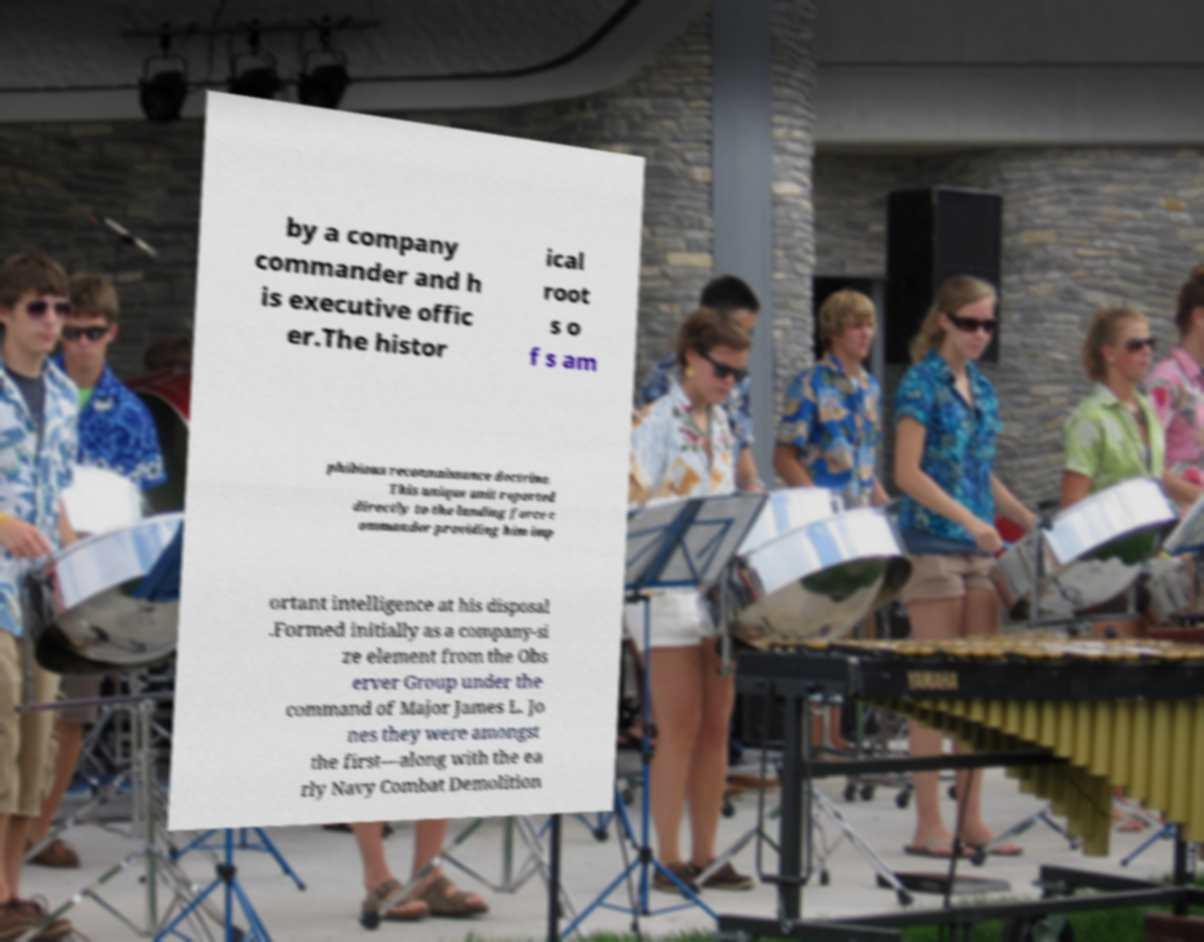Could you extract and type out the text from this image? by a company commander and h is executive offic er.The histor ical root s o f s am phibious reconnaissance doctrine. This unique unit reported directly to the landing force c ommander providing him imp ortant intelligence at his disposal .Formed initially as a company-si ze element from the Obs erver Group under the command of Major James L. Jo nes they were amongst the first—along with the ea rly Navy Combat Demolition 